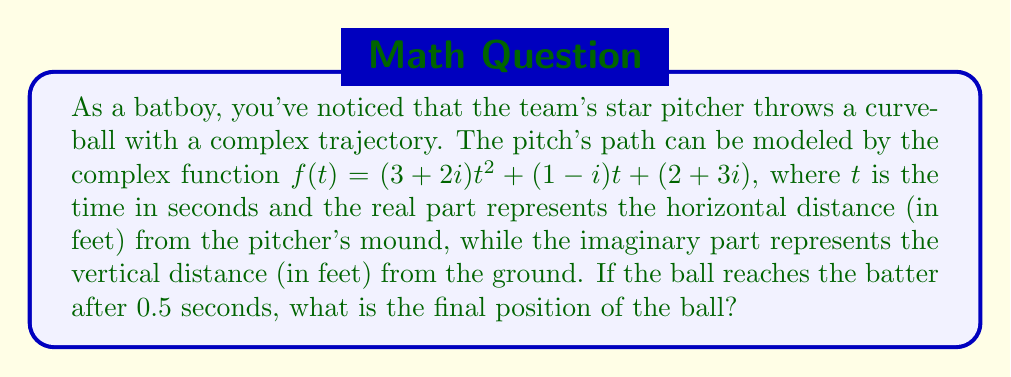Could you help me with this problem? To find the final position of the ball, we need to evaluate the complex function $f(t)$ at $t = 0.5$ seconds. Let's break this down step-by-step:

1) We have $f(t) = (3+2i)t^2 + (1-i)t + (2+3i)$

2) Substituting $t = 0.5$:
   $f(0.5) = (3+2i)(0.5)^2 + (1-i)(0.5) + (2+3i)$

3) Let's calculate each term:
   a) $(3+2i)(0.5)^2 = (3+2i)(0.25) = 0.75 + 0.5i$
   b) $(1-i)(0.5) = 0.5 - 0.5i$
   c) $(2+3i)$ remains as is

4) Now, let's add these terms:
   $f(0.5) = (0.75 + 0.5i) + (0.5 - 0.5i) + (2+3i)$

5) Combining real and imaginary parts:
   $f(0.5) = (0.75 + 0.5 + 2) + (0.5 - 0.5 + 3)i$

6) Simplifying:
   $f(0.5) = 3.25 + 3i$

Therefore, after 0.5 seconds, the ball is at position $3.25 + 3i$ feet.
Answer: $3.25 + 3i$ feet 